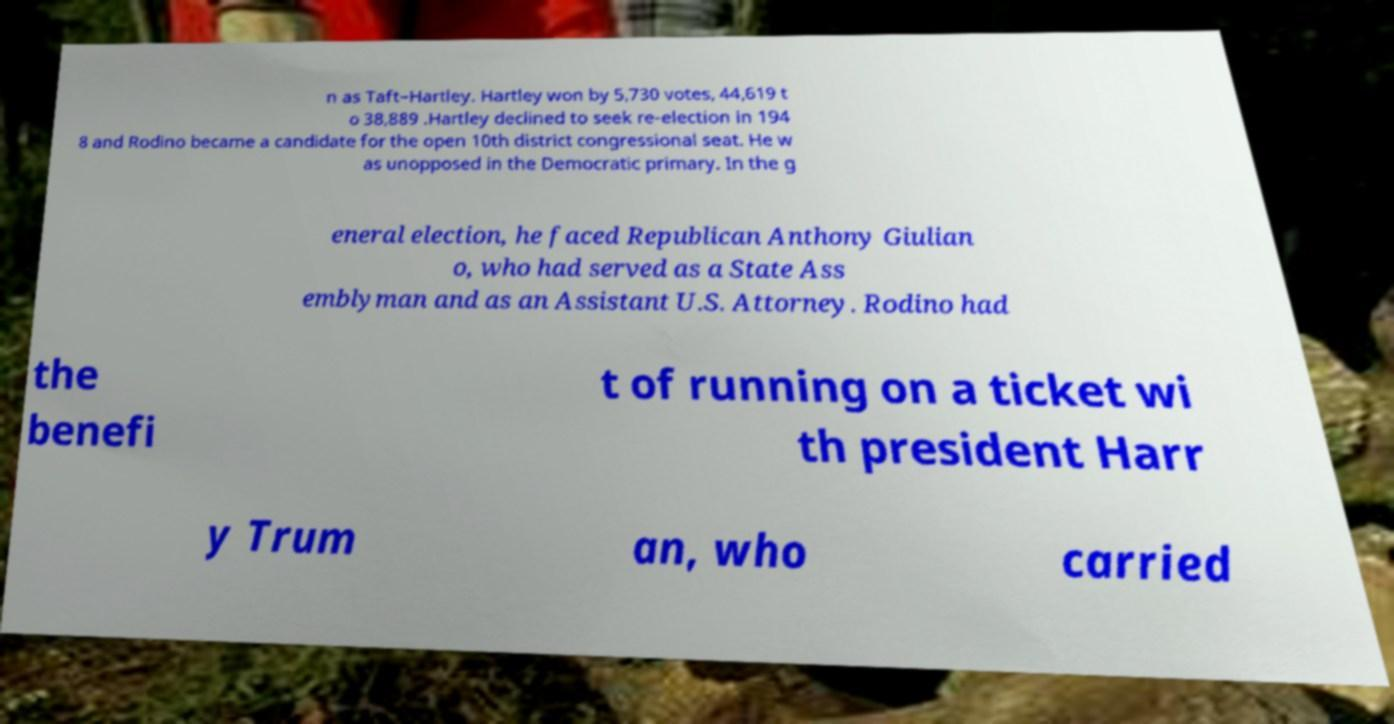Please read and relay the text visible in this image. What does it say? n as Taft–Hartley. Hartley won by 5,730 votes, 44,619 t o 38,889 .Hartley declined to seek re-election in 194 8 and Rodino became a candidate for the open 10th district congressional seat. He w as unopposed in the Democratic primary. In the g eneral election, he faced Republican Anthony Giulian o, who had served as a State Ass emblyman and as an Assistant U.S. Attorney. Rodino had the benefi t of running on a ticket wi th president Harr y Trum an, who carried 